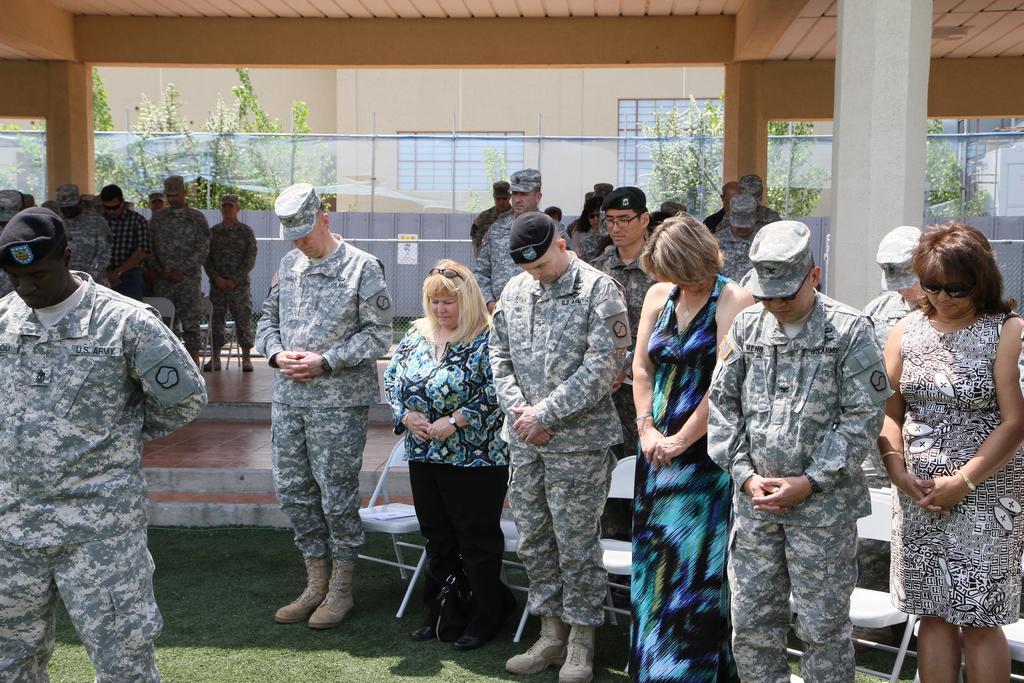How would you summarize this image in a sentence or two? In the picture I can see people wearing army uniforms, caps and shoes and few more women wearing dresses are bowing their heads and standing on the grass. Here we can see the chairs, pillars, fence, trees and the house in the background. 